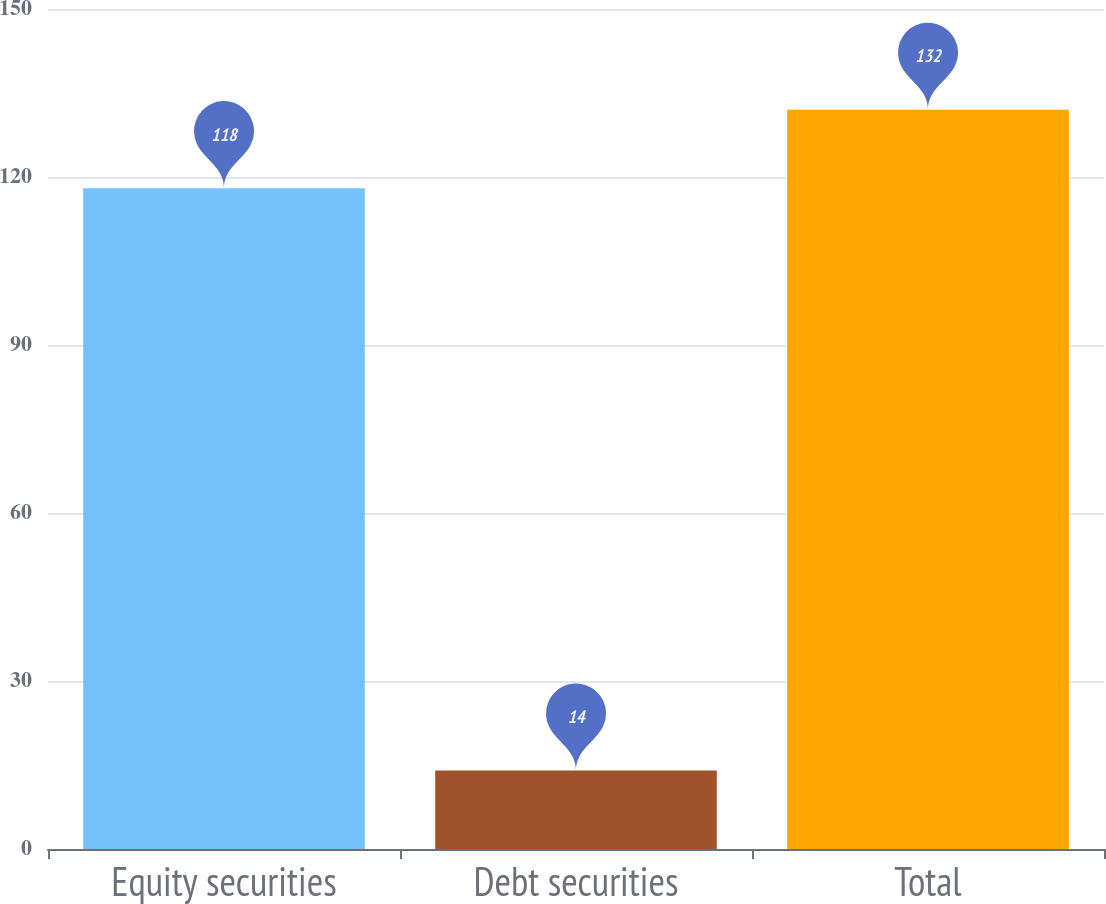Convert chart. <chart><loc_0><loc_0><loc_500><loc_500><bar_chart><fcel>Equity securities<fcel>Debt securities<fcel>Total<nl><fcel>118<fcel>14<fcel>132<nl></chart> 